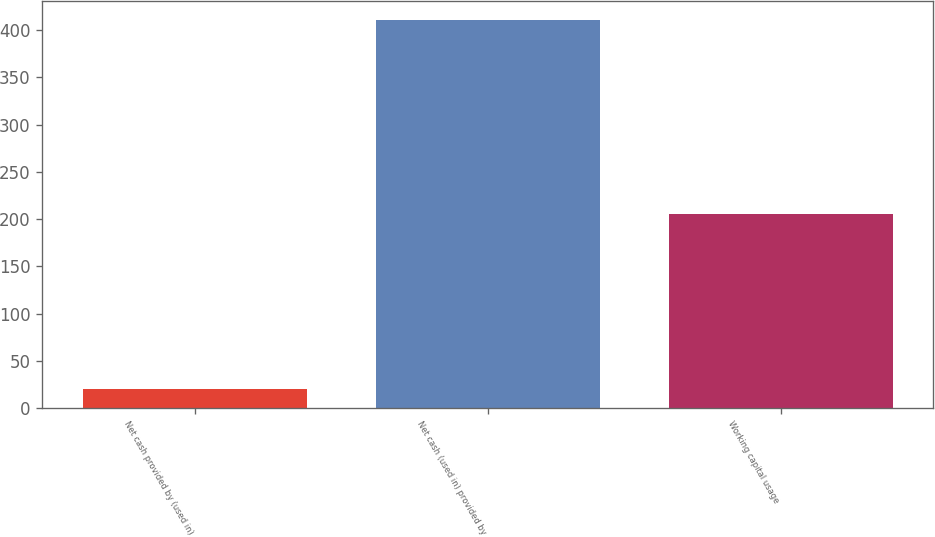<chart> <loc_0><loc_0><loc_500><loc_500><bar_chart><fcel>Net cash provided by (used in)<fcel>Net cash (used in) provided by<fcel>Working capital usage<nl><fcel>20.2<fcel>410.1<fcel>205.39<nl></chart> 